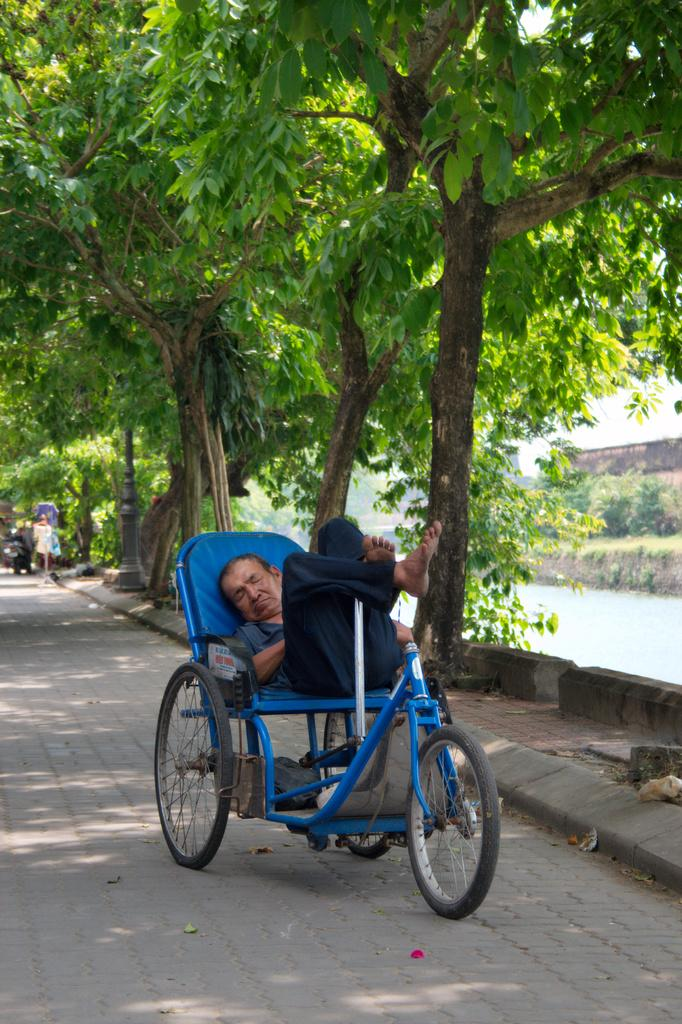Who is the person in the image? There is a man in the image. What is the man doing in the image? The man is on a bicycle. What can be seen in the background of the image? There are trees, the sky, and a road visible in the background of the image. Where is the man's aunt in the image? There is no mention of an aunt in the image, so we cannot determine her location. What type of cloth is draped over the bicycle in the image? There is no cloth draped over the bicycle in the image. 